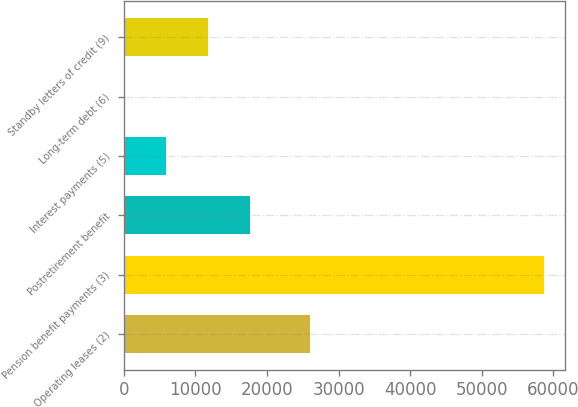Convert chart to OTSL. <chart><loc_0><loc_0><loc_500><loc_500><bar_chart><fcel>Operating leases (2)<fcel>Pension benefit payments (3)<fcel>Postretirement benefit<fcel>Interest payments (5)<fcel>Long-term debt (6)<fcel>Standby letters of credit (9)<nl><fcel>26042<fcel>58650<fcel>17628.6<fcel>5908.2<fcel>48<fcel>11768.4<nl></chart> 